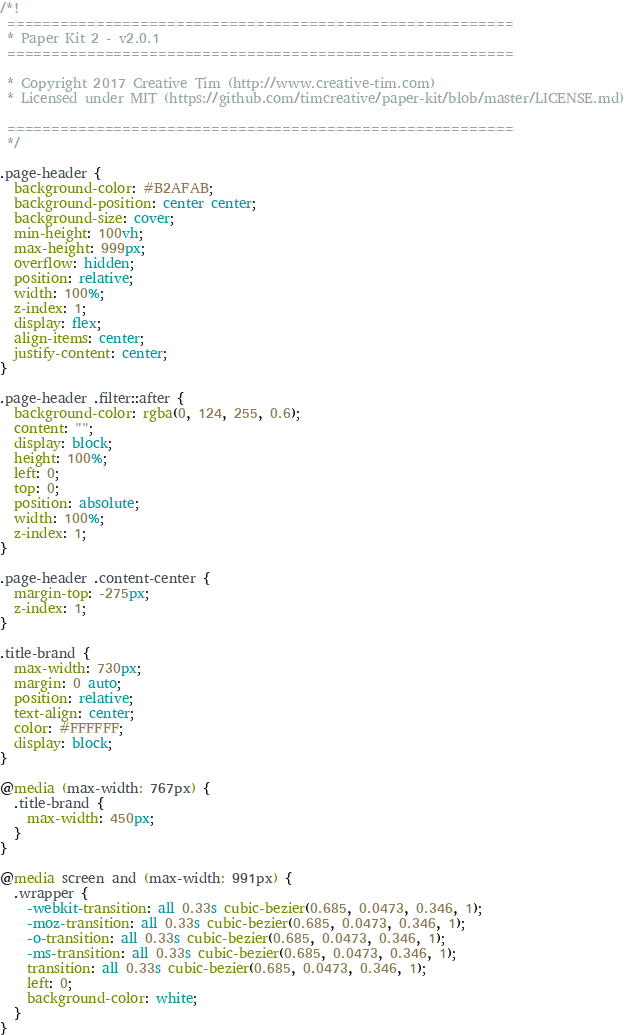Convert code to text. <code><loc_0><loc_0><loc_500><loc_500><_CSS_>/*!
 =========================================================
 * Paper Kit 2 - v2.0.1
 =========================================================

 * Copyright 2017 Creative Tim (http://www.creative-tim.com)
 * Licensed under MIT (https://github.com/timcreative/paper-kit/blob/master/LICENSE.md)

 =========================================================
 */

.page-header {
  background-color: #B2AFAB;
  background-position: center center;
  background-size: cover;
  min-height: 100vh;
  max-height: 999px;
  overflow: hidden;
  position: relative;
  width: 100%;
  z-index: 1;
  display: flex;
  align-items: center;
  justify-content: center;
}

.page-header .filter::after {
  background-color: rgba(0, 124, 255, 0.6);
  content: "";
  display: block;
  height: 100%;
  left: 0;
  top: 0;
  position: absolute;
  width: 100%;
  z-index: 1;
}

.page-header .content-center {
  margin-top: -275px;
  z-index: 1;
}

.title-brand {
  max-width: 730px;
  margin: 0 auto;
  position: relative;
  text-align: center;
  color: #FFFFFF;
  display: block;
}

@media (max-width: 767px) {
  .title-brand {
    max-width: 450px;
  }
}

@media screen and (max-width: 991px) {
  .wrapper {
    -webkit-transition: all 0.33s cubic-bezier(0.685, 0.0473, 0.346, 1);
    -moz-transition: all 0.33s cubic-bezier(0.685, 0.0473, 0.346, 1);
    -o-transition: all 0.33s cubic-bezier(0.685, 0.0473, 0.346, 1);
    -ms-transition: all 0.33s cubic-bezier(0.685, 0.0473, 0.346, 1);
    transition: all 0.33s cubic-bezier(0.685, 0.0473, 0.346, 1);
    left: 0;
    background-color: white;
  }
}
</code> 